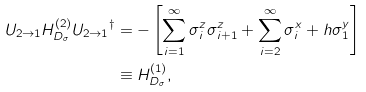Convert formula to latex. <formula><loc_0><loc_0><loc_500><loc_500>U _ { 2 \rightarrow 1 } H _ { D _ { \sigma } } ^ { ( 2 ) } { U _ { 2 \rightarrow 1 } } ^ { \dagger } & = - \left [ \sum _ { i = 1 } ^ { \infty } \sigma _ { i } ^ { z } \sigma _ { i + 1 } ^ { z } + \sum _ { i = 2 } ^ { \infty } \sigma _ { i } ^ { x } + h \sigma _ { 1 } ^ { y } \right ] \\ & \equiv H _ { D _ { \sigma } } ^ { ( 1 ) } ,</formula> 